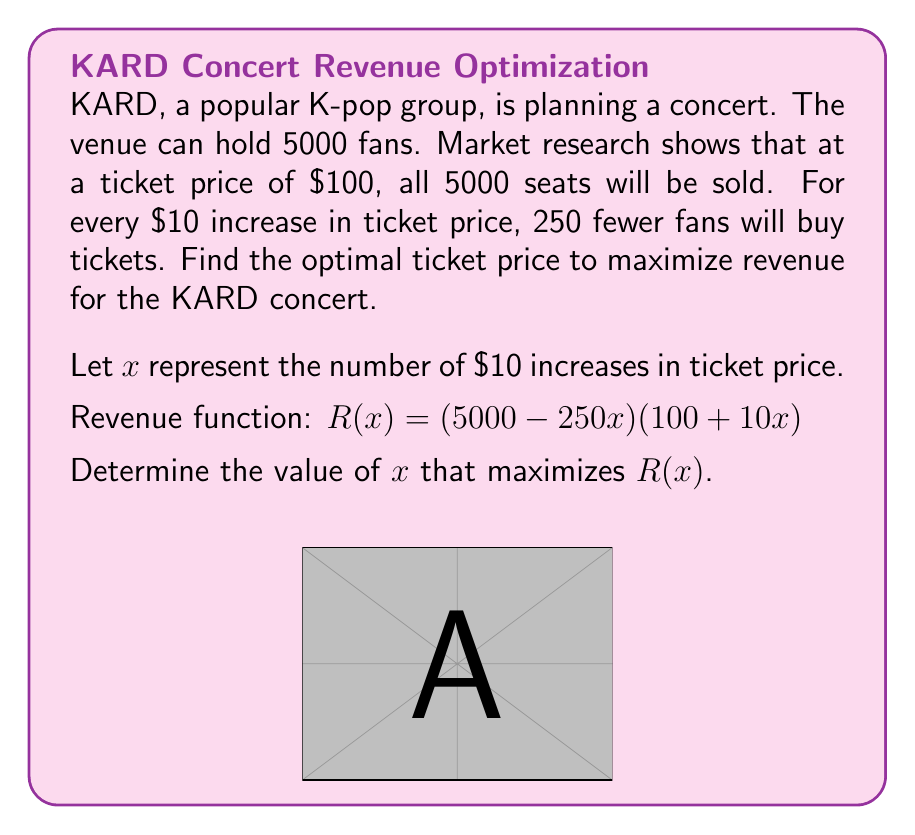Can you answer this question? 1) First, expand the revenue function:
   $R(x) = (5000 - 250x)(100 + 10x)$
   $R(x) = 500000 + 50000x - 25000x - 2500x^2$
   $R(x) = -2500x^2 + 25000x + 500000$

2) To find the maximum, we need to find the vertex of this quadratic function. We can use the formula $x = -\frac{b}{2a}$ where $a$ and $b$ are the coefficients of the quadratic function in standard form $(ax^2 + bx + c)$.

3) In this case, $a = -2500$ and $b = 25000$

4) $x = -\frac{25000}{2(-2500)} = 5$

5) This means the optimal price increase is $5 * $10 = $50$

6) Therefore, the optimal ticket price is $100 + $50 = $150$

7) To verify, we can calculate the revenue at $x = 4, 5, 6$:
   $R(4) = -2500(16) + 25000(4) + 500000 = 580000$
   $R(5) = -2500(25) + 25000(5) + 500000 = 562500$
   $R(6) = -2500(36) + 25000(6) + 500000 = 560000$

   This confirms that $x = 5$ gives the maximum revenue.
Answer: $150 